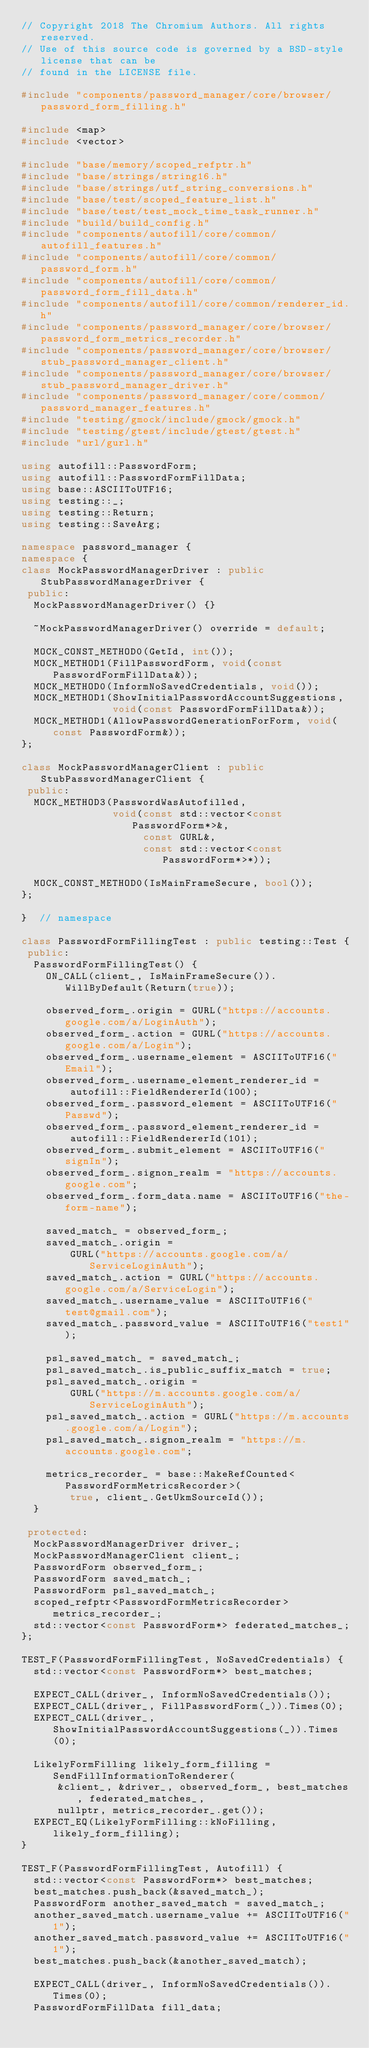Convert code to text. <code><loc_0><loc_0><loc_500><loc_500><_C++_>// Copyright 2018 The Chromium Authors. All rights reserved.
// Use of this source code is governed by a BSD-style license that can be
// found in the LICENSE file.

#include "components/password_manager/core/browser/password_form_filling.h"

#include <map>
#include <vector>

#include "base/memory/scoped_refptr.h"
#include "base/strings/string16.h"
#include "base/strings/utf_string_conversions.h"
#include "base/test/scoped_feature_list.h"
#include "base/test/test_mock_time_task_runner.h"
#include "build/build_config.h"
#include "components/autofill/core/common/autofill_features.h"
#include "components/autofill/core/common/password_form.h"
#include "components/autofill/core/common/password_form_fill_data.h"
#include "components/autofill/core/common/renderer_id.h"
#include "components/password_manager/core/browser/password_form_metrics_recorder.h"
#include "components/password_manager/core/browser/stub_password_manager_client.h"
#include "components/password_manager/core/browser/stub_password_manager_driver.h"
#include "components/password_manager/core/common/password_manager_features.h"
#include "testing/gmock/include/gmock/gmock.h"
#include "testing/gtest/include/gtest/gtest.h"
#include "url/gurl.h"

using autofill::PasswordForm;
using autofill::PasswordFormFillData;
using base::ASCIIToUTF16;
using testing::_;
using testing::Return;
using testing::SaveArg;

namespace password_manager {
namespace {
class MockPasswordManagerDriver : public StubPasswordManagerDriver {
 public:
  MockPasswordManagerDriver() {}

  ~MockPasswordManagerDriver() override = default;

  MOCK_CONST_METHOD0(GetId, int());
  MOCK_METHOD1(FillPasswordForm, void(const PasswordFormFillData&));
  MOCK_METHOD0(InformNoSavedCredentials, void());
  MOCK_METHOD1(ShowInitialPasswordAccountSuggestions,
               void(const PasswordFormFillData&));
  MOCK_METHOD1(AllowPasswordGenerationForForm, void(const PasswordForm&));
};

class MockPasswordManagerClient : public StubPasswordManagerClient {
 public:
  MOCK_METHOD3(PasswordWasAutofilled,
               void(const std::vector<const PasswordForm*>&,
                    const GURL&,
                    const std::vector<const PasswordForm*>*));

  MOCK_CONST_METHOD0(IsMainFrameSecure, bool());
};

}  // namespace

class PasswordFormFillingTest : public testing::Test {
 public:
  PasswordFormFillingTest() {
    ON_CALL(client_, IsMainFrameSecure()).WillByDefault(Return(true));

    observed_form_.origin = GURL("https://accounts.google.com/a/LoginAuth");
    observed_form_.action = GURL("https://accounts.google.com/a/Login");
    observed_form_.username_element = ASCIIToUTF16("Email");
    observed_form_.username_element_renderer_id =
        autofill::FieldRendererId(100);
    observed_form_.password_element = ASCIIToUTF16("Passwd");
    observed_form_.password_element_renderer_id =
        autofill::FieldRendererId(101);
    observed_form_.submit_element = ASCIIToUTF16("signIn");
    observed_form_.signon_realm = "https://accounts.google.com";
    observed_form_.form_data.name = ASCIIToUTF16("the-form-name");

    saved_match_ = observed_form_;
    saved_match_.origin =
        GURL("https://accounts.google.com/a/ServiceLoginAuth");
    saved_match_.action = GURL("https://accounts.google.com/a/ServiceLogin");
    saved_match_.username_value = ASCIIToUTF16("test@gmail.com");
    saved_match_.password_value = ASCIIToUTF16("test1");

    psl_saved_match_ = saved_match_;
    psl_saved_match_.is_public_suffix_match = true;
    psl_saved_match_.origin =
        GURL("https://m.accounts.google.com/a/ServiceLoginAuth");
    psl_saved_match_.action = GURL("https://m.accounts.google.com/a/Login");
    psl_saved_match_.signon_realm = "https://m.accounts.google.com";

    metrics_recorder_ = base::MakeRefCounted<PasswordFormMetricsRecorder>(
        true, client_.GetUkmSourceId());
  }

 protected:
  MockPasswordManagerDriver driver_;
  MockPasswordManagerClient client_;
  PasswordForm observed_form_;
  PasswordForm saved_match_;
  PasswordForm psl_saved_match_;
  scoped_refptr<PasswordFormMetricsRecorder> metrics_recorder_;
  std::vector<const PasswordForm*> federated_matches_;
};

TEST_F(PasswordFormFillingTest, NoSavedCredentials) {
  std::vector<const PasswordForm*> best_matches;

  EXPECT_CALL(driver_, InformNoSavedCredentials());
  EXPECT_CALL(driver_, FillPasswordForm(_)).Times(0);
  EXPECT_CALL(driver_, ShowInitialPasswordAccountSuggestions(_)).Times(0);

  LikelyFormFilling likely_form_filling = SendFillInformationToRenderer(
      &client_, &driver_, observed_form_, best_matches, federated_matches_,
      nullptr, metrics_recorder_.get());
  EXPECT_EQ(LikelyFormFilling::kNoFilling, likely_form_filling);
}

TEST_F(PasswordFormFillingTest, Autofill) {
  std::vector<const PasswordForm*> best_matches;
  best_matches.push_back(&saved_match_);
  PasswordForm another_saved_match = saved_match_;
  another_saved_match.username_value += ASCIIToUTF16("1");
  another_saved_match.password_value += ASCIIToUTF16("1");
  best_matches.push_back(&another_saved_match);

  EXPECT_CALL(driver_, InformNoSavedCredentials()).Times(0);
  PasswordFormFillData fill_data;</code> 